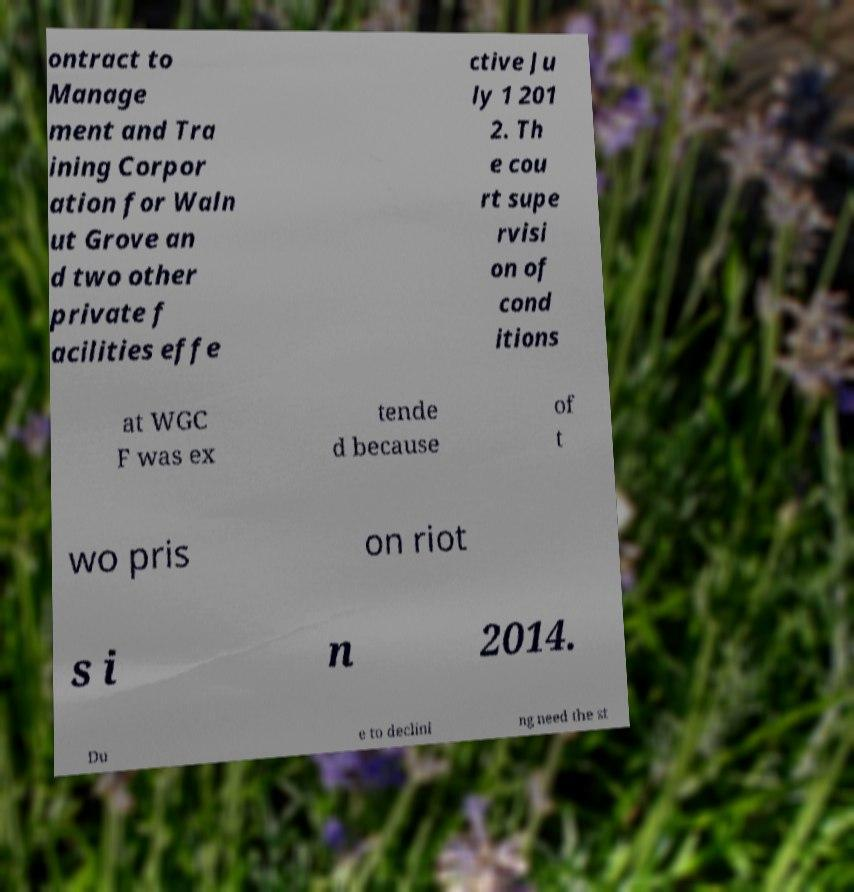There's text embedded in this image that I need extracted. Can you transcribe it verbatim? ontract to Manage ment and Tra ining Corpor ation for Waln ut Grove an d two other private f acilities effe ctive Ju ly 1 201 2. Th e cou rt supe rvisi on of cond itions at WGC F was ex tende d because of t wo pris on riot s i n 2014. Du e to declini ng need the st 